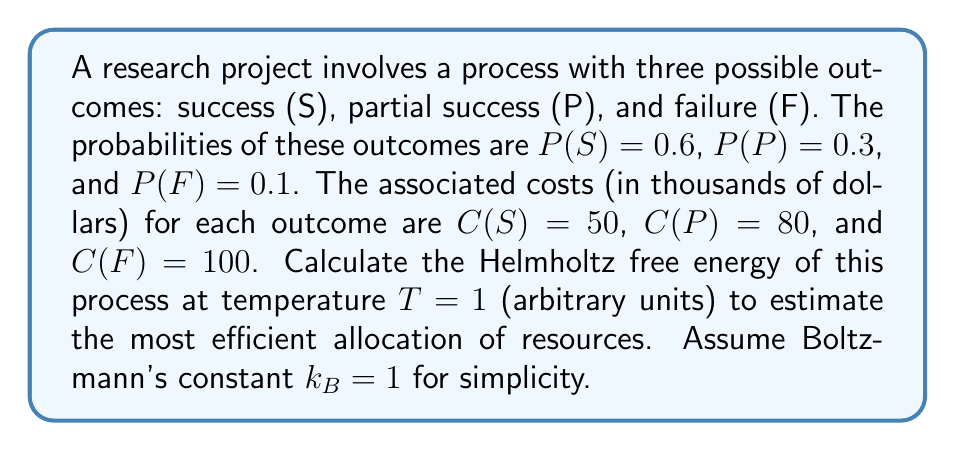Provide a solution to this math problem. To calculate the Helmholtz free energy, we'll use the formula:

$$F = U - TS$$

Where:
$F$ is the Helmholtz free energy
$U$ is the internal energy (average cost in this case)
$T$ is the temperature (given as 1)
$S$ is the entropy

Step 1: Calculate the internal energy (average cost)
$$U = P(S)C(S) + P(P)C(P) + P(F)C(F)$$
$$U = 0.6 \times 50 + 0.3 \times 80 + 0.1 \times 100 = 30 + 24 + 10 = 64$$

Step 2: Calculate the entropy
$$S = -k_B\sum_i P_i \ln P_i$$
$$S = -(0.6 \ln 0.6 + 0.3 \ln 0.3 + 0.1 \ln 0.1)$$
$$S = -(0.6 \times (-0.51083) + 0.3 \times (-1.20397) + 0.1 \times (-2.30259))$$
$$S = 0.30650 + 0.36119 + 0.23026 = 0.89795$$

Step 3: Calculate the Helmholtz free energy
$$F = U - TS = 64 - 1 \times 0.89795 = 63.10205$$

The Helmholtz free energy of the research process is approximately 63.10 thousand dollars.
Answer: $63.10$ thousand dollars 